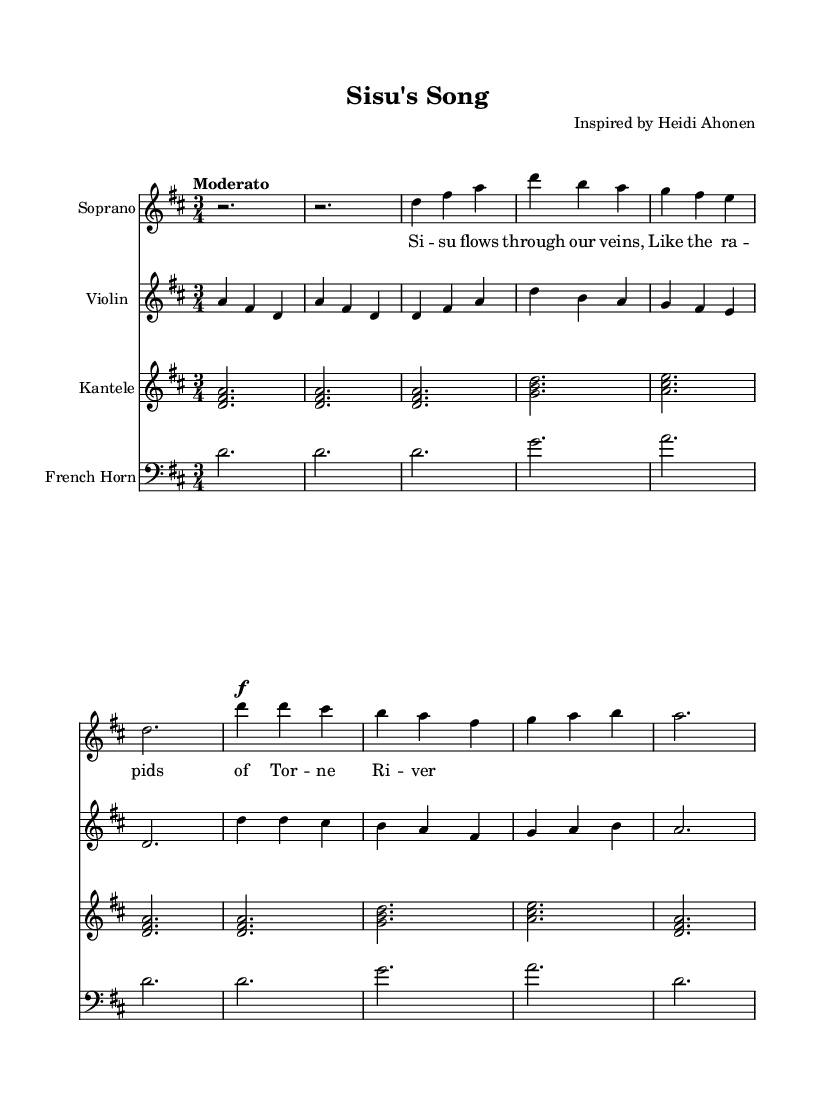What is the key signature of this music? The key signature appears at the beginning of the score. It shows two sharps, which indicates that the music is in D major.
Answer: D major What is the time signature of this piece? The time signature is located at the beginning of the score, around the key signature. It displays a "3/4" time signature, indicating that there are three beats in each measure and a quarter note gets one beat.
Answer: 3/4 What is the tempo marking for this piece? The tempo marking is found at the beginning of the score, written above the music. It states "Moderato", which indicates a moderate tempo for the piece.
Answer: Moderato How many verses are in this piece? By analyzing the structure shown in the score, it is clear that there is at least one verse presented, indicated by a section labeled "Verse 1." The presence of a chorus suggests additional vocal sections, but only one verse is indicated here.
Answer: One What instruments are used in this composition? The score lists the instruments at the beginning, which include Soprano, Violin, Kantele, and French Horn. These are explicitly stated in the staff labels.
Answer: Soprano, Violin, Kantele, French Horn What is the dynamic marking for the chorus section? The dynamic marking is indicated by the symbol "\f", which stands for "forte", suggesting that the chorus should be played loudly. This marking is found at the beginning of the chorus section.
Answer: Forte 